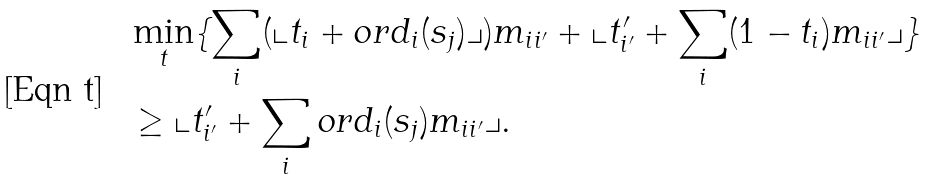Convert formula to latex. <formula><loc_0><loc_0><loc_500><loc_500>& \min _ { t } \{ \sum _ { i } ( \llcorner t _ { i } + o r d _ { i } ( s _ { j } ) \lrcorner ) m _ { i i ^ { \prime } } + \llcorner t ^ { \prime } _ { i ^ { \prime } } + \sum _ { i } ( 1 - t _ { i } ) m _ { i i ^ { \prime } } \lrcorner \} \\ & \geq \llcorner t ^ { \prime } _ { i ^ { \prime } } + \sum _ { i } o r d _ { i } ( s _ { j } ) m _ { i i ^ { \prime } } \lrcorner .</formula> 